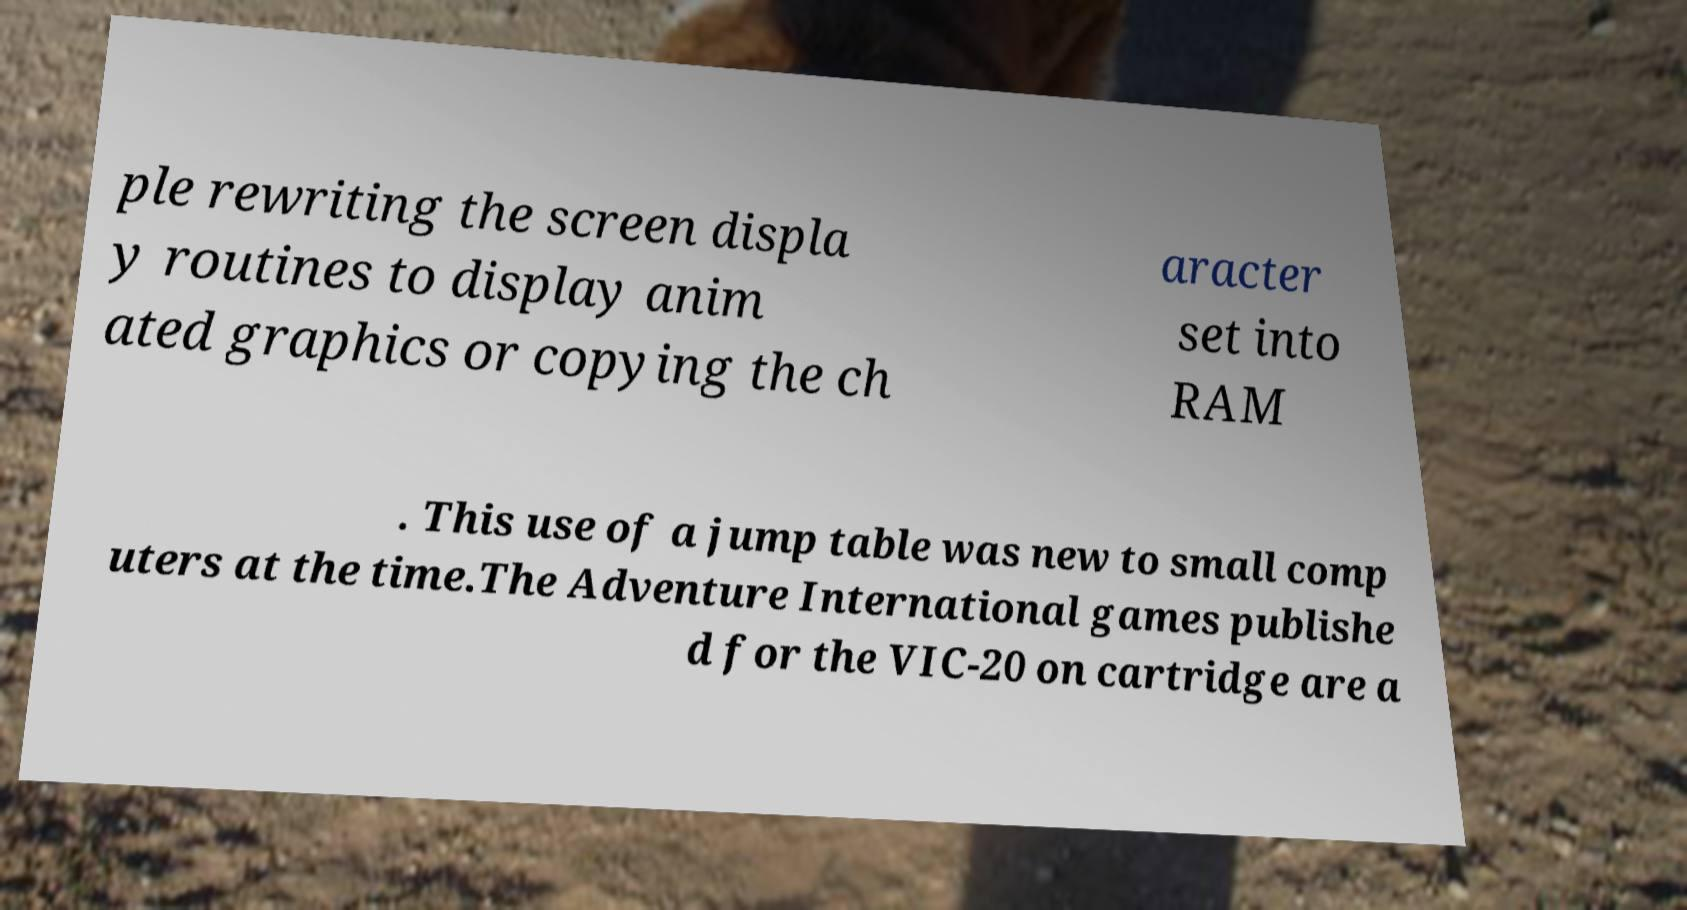Could you assist in decoding the text presented in this image and type it out clearly? ple rewriting the screen displa y routines to display anim ated graphics or copying the ch aracter set into RAM . This use of a jump table was new to small comp uters at the time.The Adventure International games publishe d for the VIC-20 on cartridge are a 